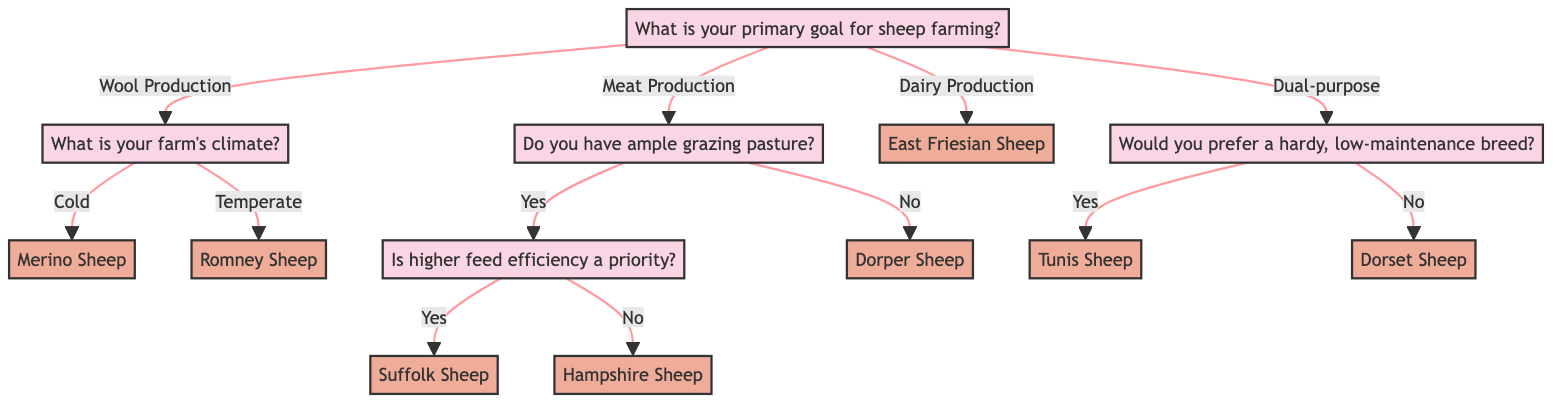What is the primary goal for sheep farming in the diagram? The diagram starts with the root question, "What is your primary goal for sheep farming?" The possible responses listed directly under this node are "Wool Production," "Meat Production," "Dairy Production," and "Dual-purpose (Wool and Meat)."
Answer: Wool Production, Meat Production, Dairy Production, Dual-purpose (Wool and Meat) What sheep breed is suggested for cold climates focused on wool production? Following the "Wool Production" option, the next question asks about the farm's climate. Under the "Cold" response, the result is "Merino Sheep."
Answer: Merino Sheep How many meat production options are there if grazing pasture is abundant? For "Meat Production," if there is ample grazing pasture, the diagram branches into two further questions regarding feed efficiency. Therefore, there are two outcomes based on the options "Yes" or "No," leading to two breeds: "Suffolk Sheep" and "Hampshire Sheep."
Answer: 2 Which breed is recommended if higher feed efficiency is not a priority in meat production? If the answer to the abundant grazing pasture question is "Yes," the next question asks if higher feed efficiency is a priority. Responding "No" leads to the breed "Hampshire Sheep."
Answer: Hampshire Sheep What breed is suggested for a dual-purpose, low-maintenance sheep? If the primary goal is "Dual-purpose (Wool and Meat)" and the preferred query for low-maintenance breeds is answered with "Yes," the breed suggested is "Tunis Sheep."
Answer: Tunis Sheep What is the result for dairy production regardless of other factors? The option labeled "Dairy Production" directly provides a result without further sub-questions. The recommended breed in this case is "East Friesian Sheep."
Answer: East Friesian Sheep What happens if the farm does not have ample grazing pasture in meat production? If the answer to having ample grazing pasture is "No," the direct outcome is "Dorper Sheep," as stated under the meat production branch.
Answer: Dorper Sheep How does the climate affect the recommended breed for wool production? The climate affects the recommendation in two ways: if the climate is "Cold," it leads to "Merino Sheep," while "Temperate" leads to "Romney Sheep." This branching shows that climate specifically dictates the choice of breed in wool production.
Answer: Merino Sheep, Romney Sheep What is the result for a dairy production goal in sheep farming? The option under dairy production has a direct outcome without further decision points, confirming that regardless of other factors, it simply results in "East Friesian Sheep."
Answer: East Friesian Sheep 